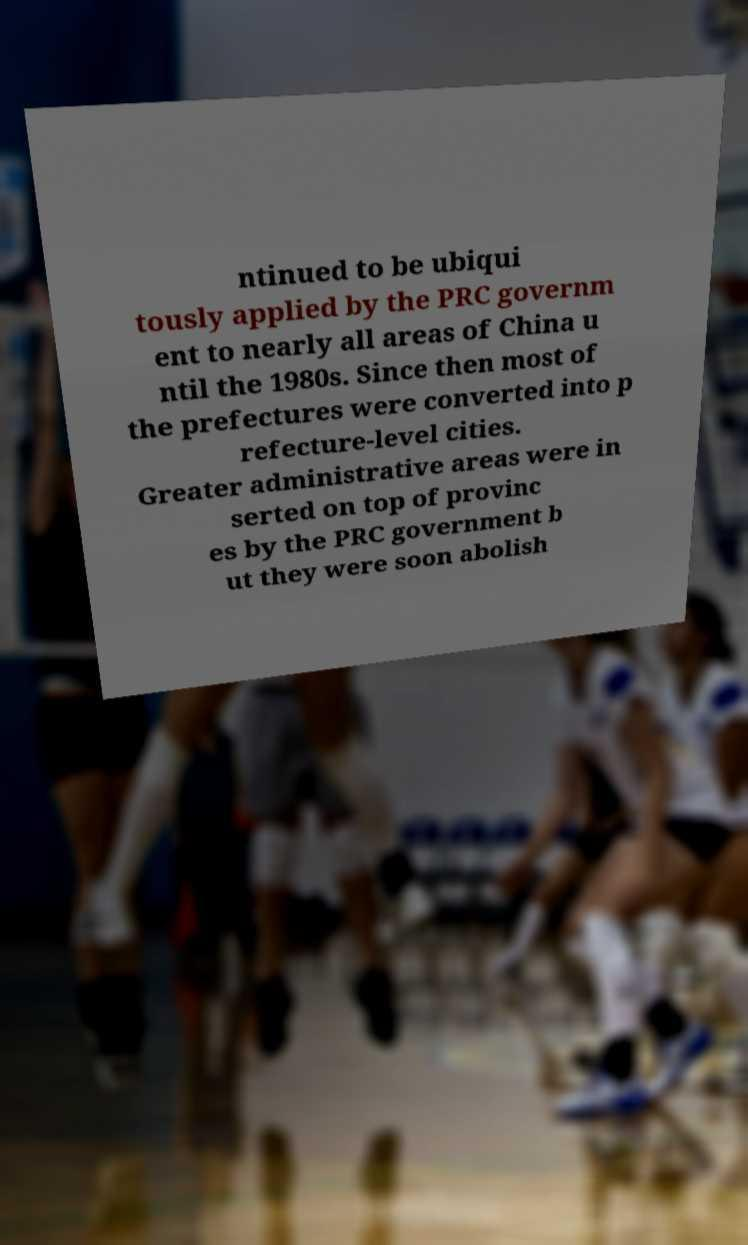Could you extract and type out the text from this image? ntinued to be ubiqui tously applied by the PRC governm ent to nearly all areas of China u ntil the 1980s. Since then most of the prefectures were converted into p refecture-level cities. Greater administrative areas were in serted on top of provinc es by the PRC government b ut they were soon abolish 